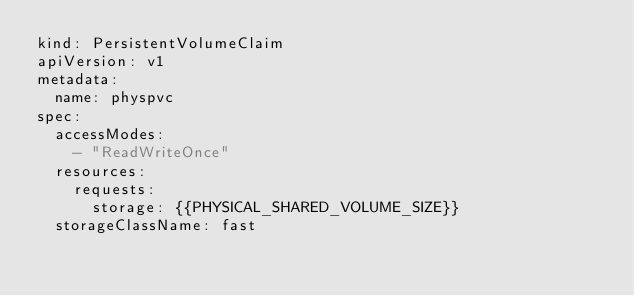Convert code to text. <code><loc_0><loc_0><loc_500><loc_500><_YAML_>kind: PersistentVolumeClaim
apiVersion: v1
metadata:
  name: physpvc
spec:
  accessModes:
    - "ReadWriteOnce"
  resources:
    requests:
      storage: {{PHYSICAL_SHARED_VOLUME_SIZE}}
  storageClassName: fast

</code> 